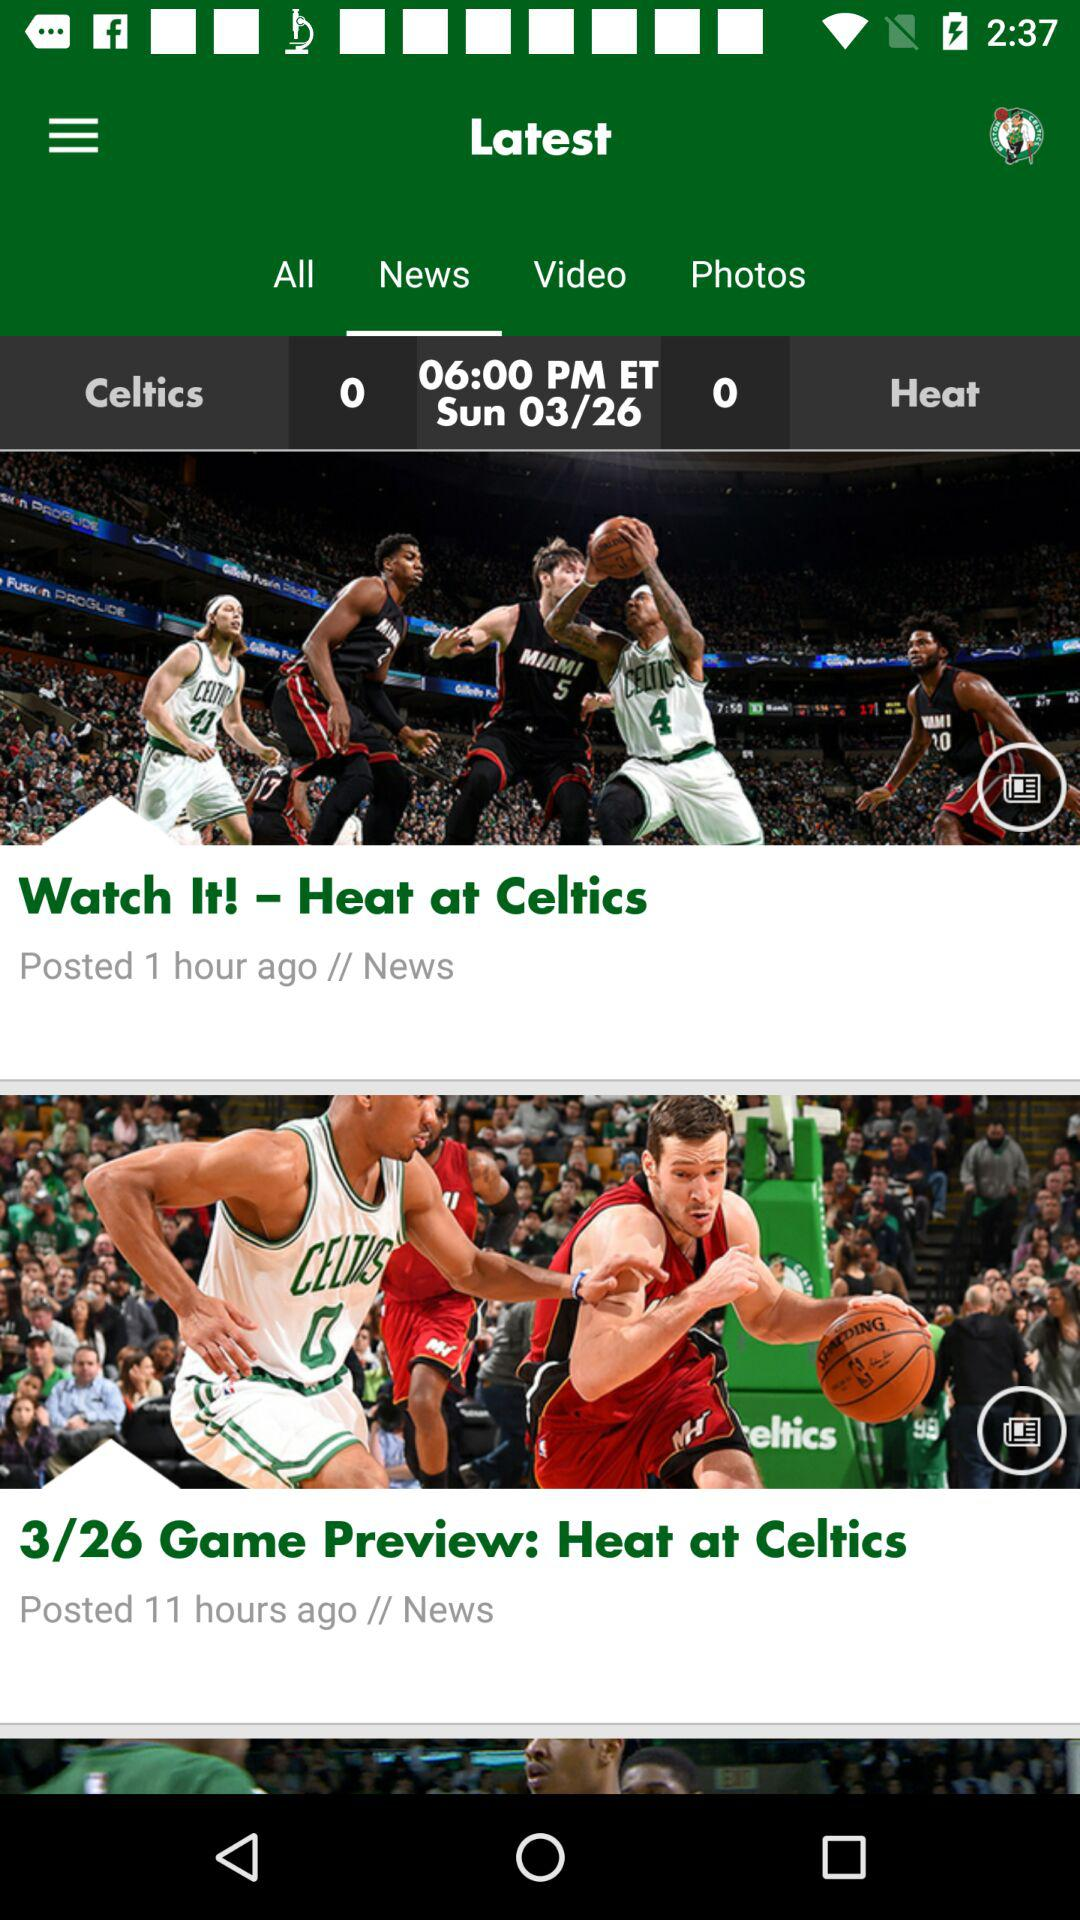When was the news broadcast? The news was broadcast on Sunday, March 26. 